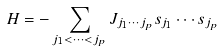<formula> <loc_0><loc_0><loc_500><loc_500>H = - \sum _ { j _ { 1 } < \cdots < j _ { p } } J _ { j _ { 1 } \cdots j _ { p } } s _ { j _ { 1 } } \cdots s _ { j _ { p } }</formula> 